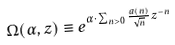<formula> <loc_0><loc_0><loc_500><loc_500>\Omega ( \alpha , z ) \equiv e ^ { \alpha \cdot \sum _ { n > 0 } \frac { a ( n ) } { \sqrt { n } } z ^ { - n } }</formula> 